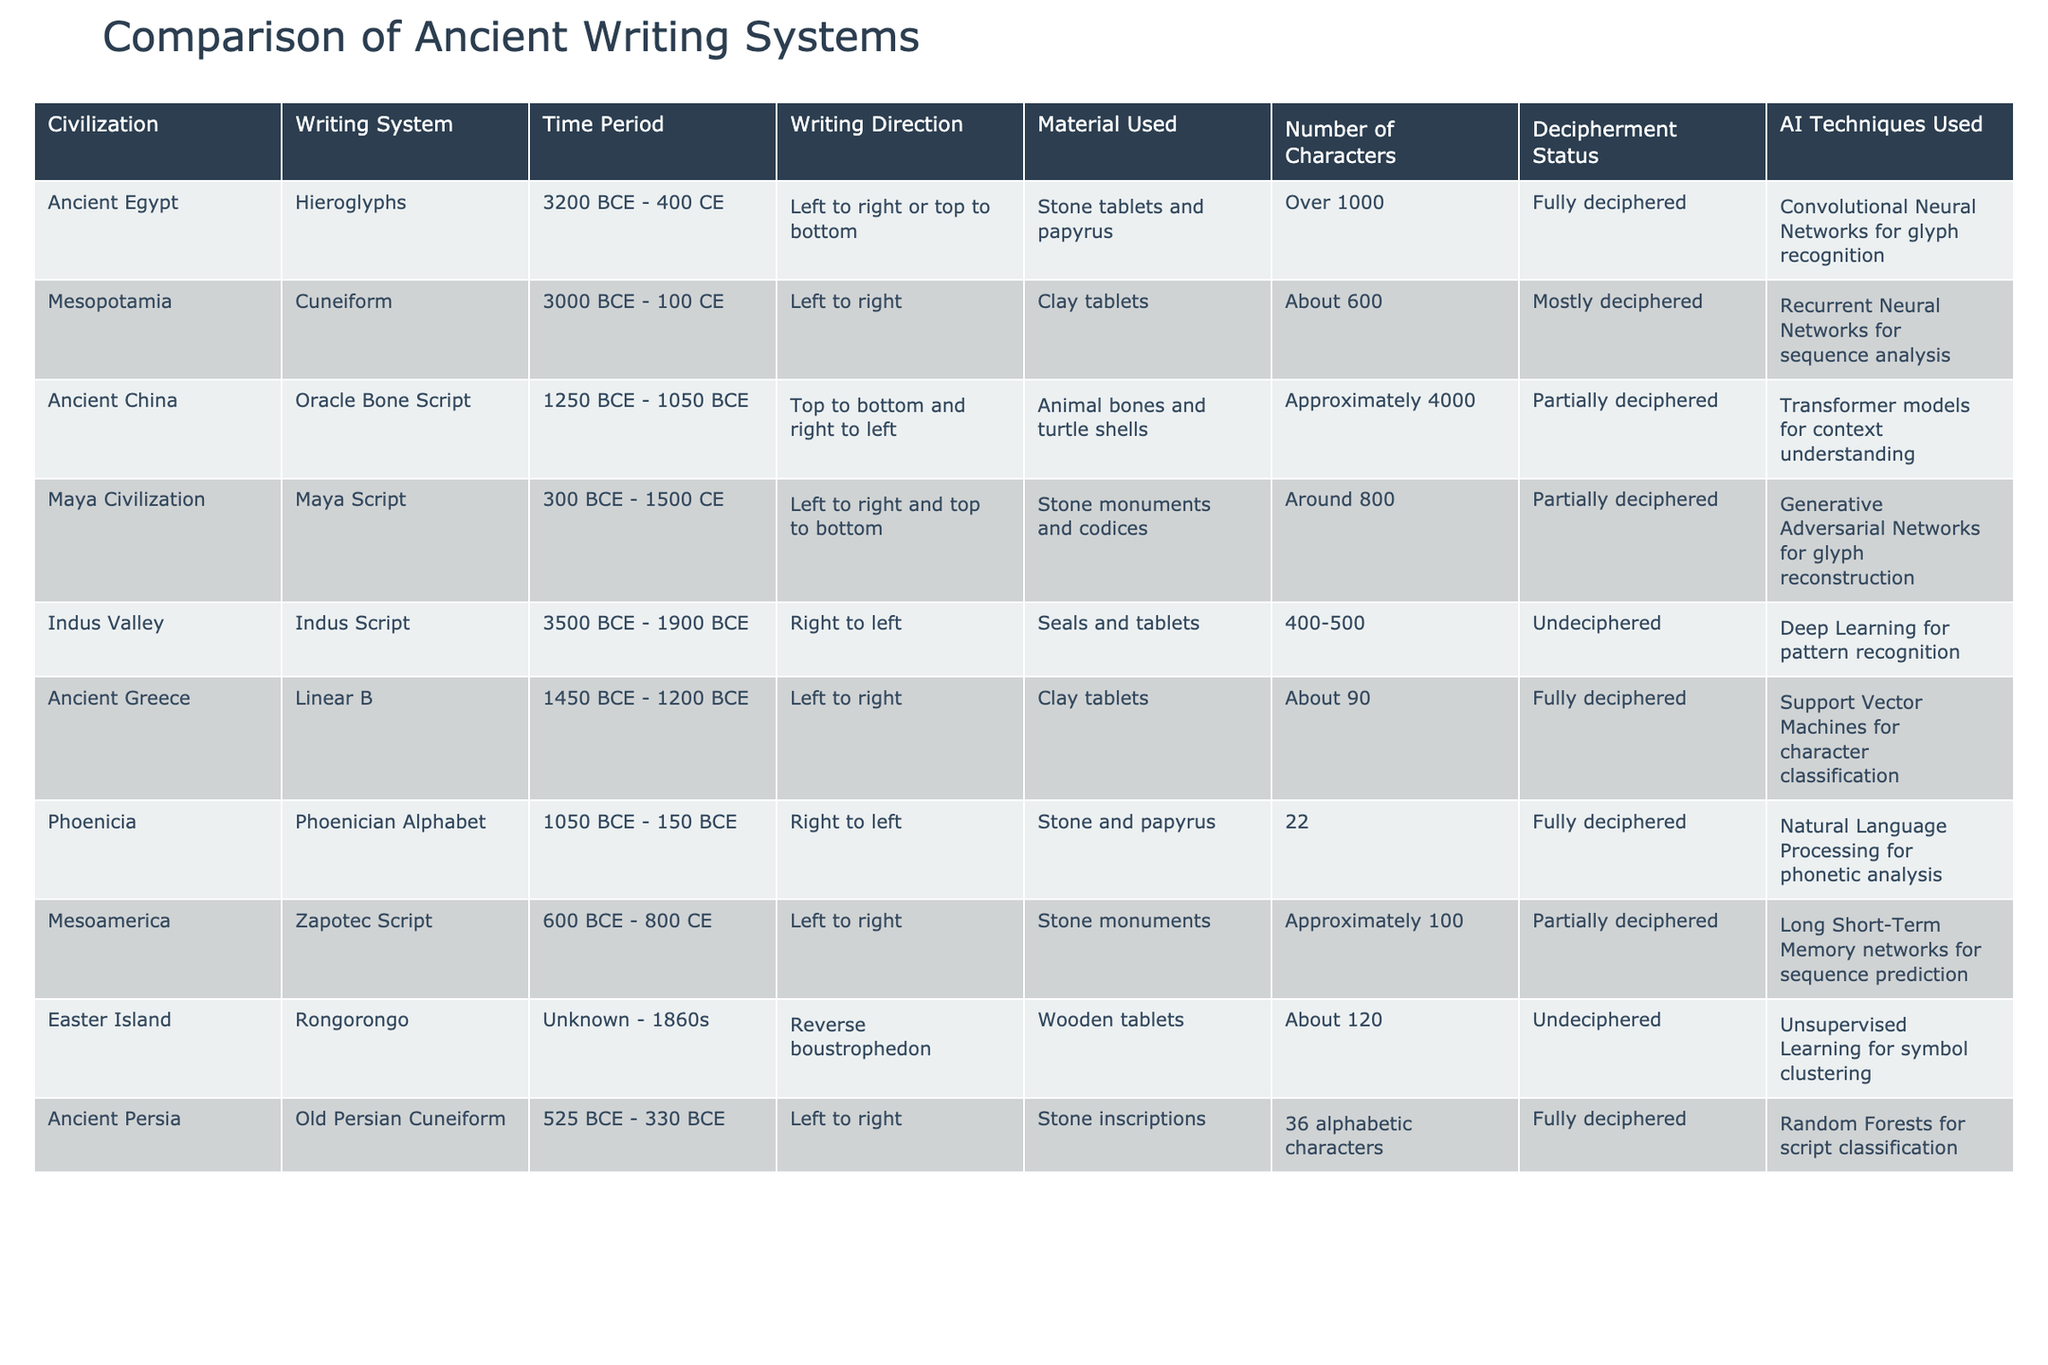What is the time period of the Maya Script? By looking at the row for the Maya Civilization, the time period for Maya Script is listed as 300 BCE - 1500 CE.
Answer: 300 BCE - 1500 CE Which writing system has the highest number of characters? The table indicates that the Oracle Bone Script from Ancient China has approximately 4000 characters, which is the highest among all writing systems listed.
Answer: Approximately 4000 Is the Indus Script deciphered? From the table, it states that the Indus Script is "Undeciphered", indicating that researchers have not yet been able to interpret it.
Answer: No How many writing systems are fully deciphered? Referring to the table, there are four fully deciphered writing systems: Hieroglyphs, Linear B, Phoenician Alphabet, and Old Persian Cuneiform.
Answer: Four What is the average number of characters for the fully deciphered writing systems? The fully deciphered writing systems and their character counts are: Hieroglyphs (Over 1000), Linear B (About 90), Phoenician Alphabet (22), and Old Persian Cuneiform (36). We cannot specify "Over 1000" as a number, so assume it to be 1000 for the average calculation. The total is 1000 + 90 + 22 + 36 = 1148. There are four systems, so the average is 1148 / 4 = 287.
Answer: 287 Which AI technique is used for glyph recognition in Ancient Egypt? The table indicates that Convolutional Neural Networks are used for glyph recognition specifically for the Hieroglyphs of Ancient Egypt.
Answer: Convolutional Neural Networks 